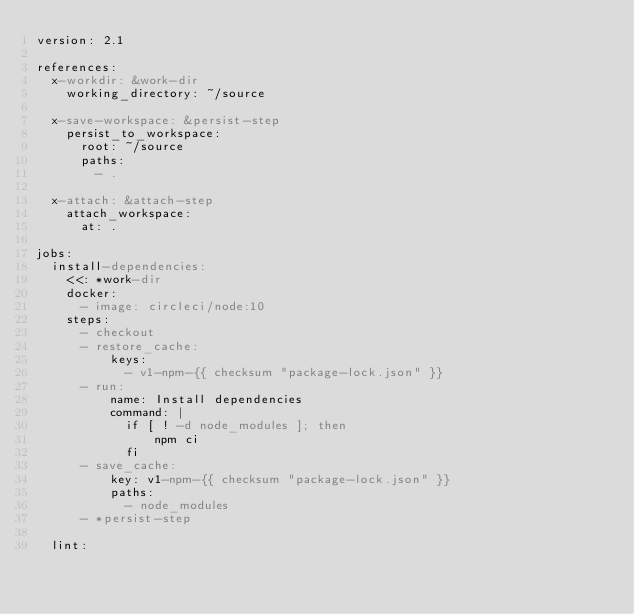Convert code to text. <code><loc_0><loc_0><loc_500><loc_500><_YAML_>version: 2.1

references:
  x-workdir: &work-dir
    working_directory: ~/source

  x-save-workspace: &persist-step
    persist_to_workspace:
      root: ~/source
      paths:
        - .

  x-attach: &attach-step
    attach_workspace:
      at: .

jobs:
  install-dependencies:
    <<: *work-dir
    docker:
      - image: circleci/node:10
    steps:
      - checkout
      - restore_cache:
          keys:
            - v1-npm-{{ checksum "package-lock.json" }}
      - run:
          name: Install dependencies
          command: |
            if [ ! -d node_modules ]; then
                npm ci
            fi
      - save_cache:
          key: v1-npm-{{ checksum "package-lock.json" }}
          paths:
            - node_modules
      - *persist-step

  lint:</code> 